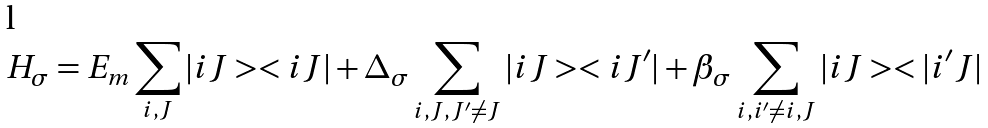Convert formula to latex. <formula><loc_0><loc_0><loc_500><loc_500>H _ { \sigma } = E _ { m } \sum _ { i , J } | i J > < i J | + \Delta _ { \sigma } \sum _ { i , J , J ^ { \prime } \neq J } | i J > < i J ^ { \prime } | + \beta _ { \sigma } \sum _ { i , i ^ { \prime } \neq i , J } | i J > < | i ^ { \prime } J |</formula> 